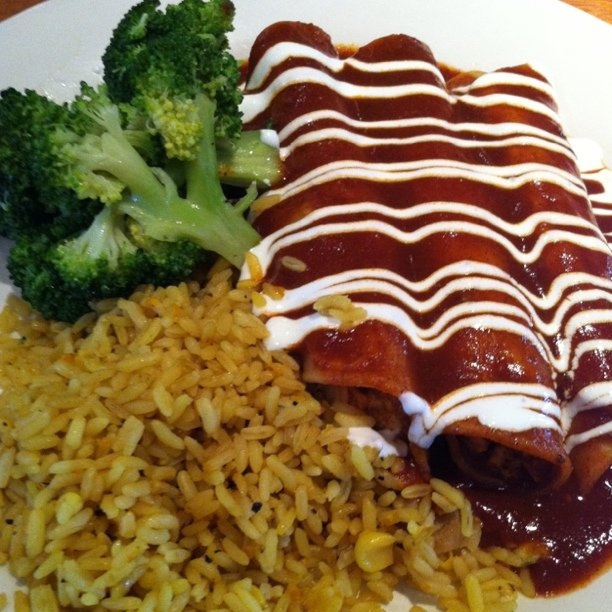Describe the objects in this image and their specific colors. I can see a broccoli in maroon, black, darkgreen, and olive tones in this image. 